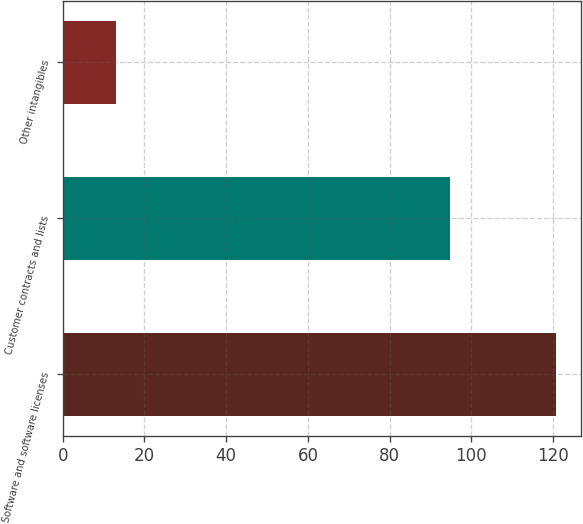<chart> <loc_0><loc_0><loc_500><loc_500><bar_chart><fcel>Software and software licenses<fcel>Customer contracts and lists<fcel>Other intangibles<nl><fcel>120.8<fcel>94.7<fcel>13<nl></chart> 